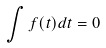Convert formula to latex. <formula><loc_0><loc_0><loc_500><loc_500>\int f ( t ) d t = 0</formula> 